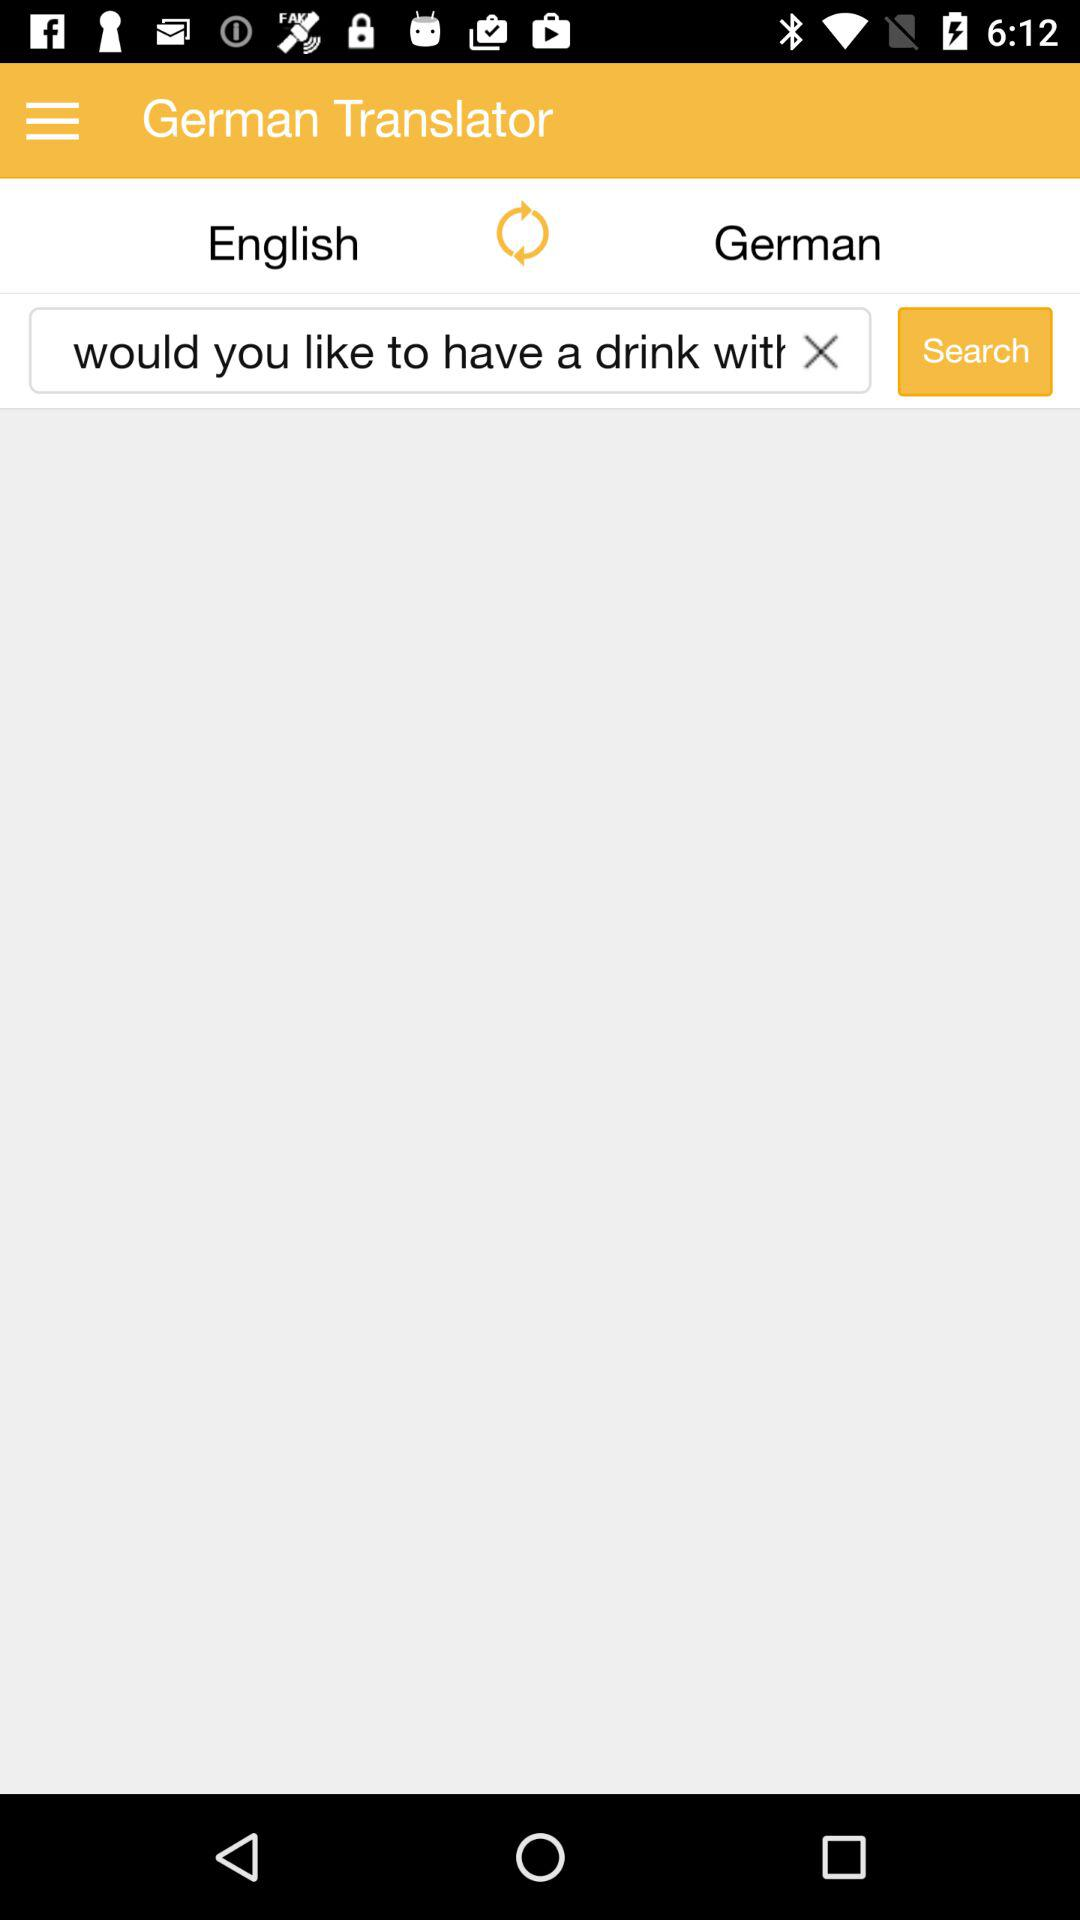The word type in which language?
When the provided information is insufficient, respond with <no answer>. <no answer> 